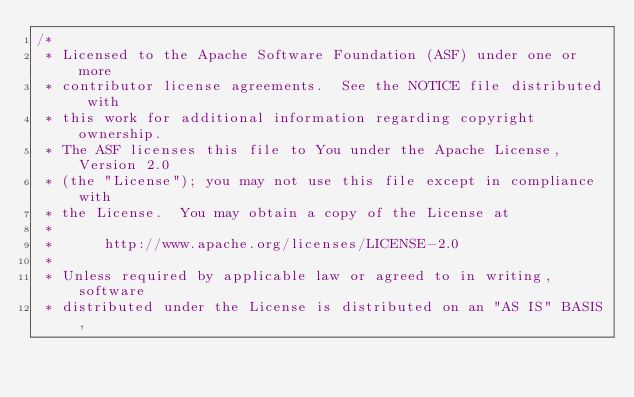<code> <loc_0><loc_0><loc_500><loc_500><_C++_>/*
 * Licensed to the Apache Software Foundation (ASF) under one or more
 * contributor license agreements.  See the NOTICE file distributed with
 * this work for additional information regarding copyright ownership.
 * The ASF licenses this file to You under the Apache License, Version 2.0
 * (the "License"); you may not use this file except in compliance with
 * the License.  You may obtain a copy of the License at
 *
 *      http://www.apache.org/licenses/LICENSE-2.0
 *
 * Unless required by applicable law or agreed to in writing, software
 * distributed under the License is distributed on an "AS IS" BASIS,</code> 